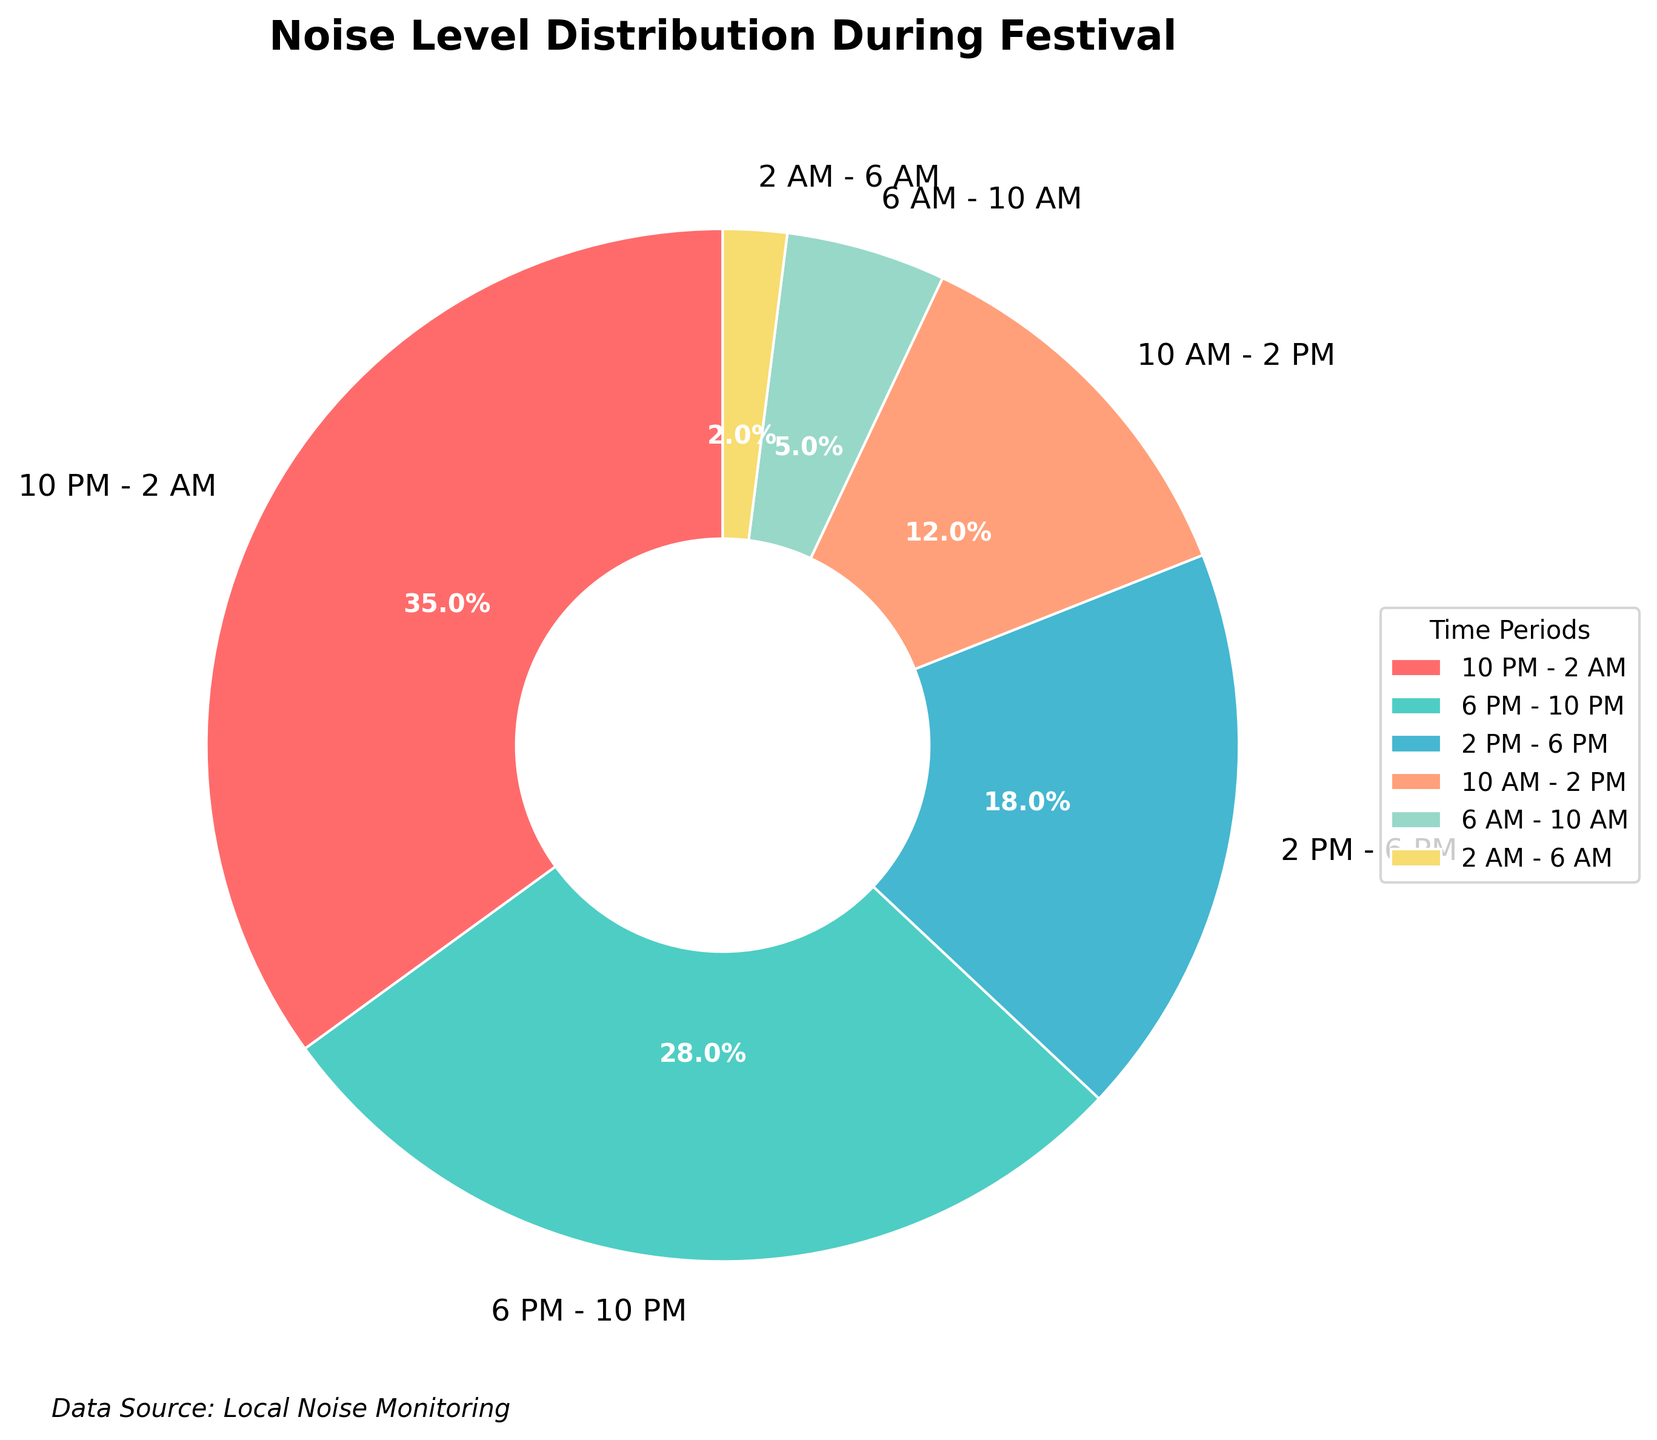Which time period has the highest noise level percentage? The slice representing "10 PM - 2 AM" has the largest portion of the pie chart, with an autopct showing 35%.
Answer: 10 PM - 2 AM What is the combined noise level percentage for the periods between 6 PM and 2 AM? The noise levels for "6 PM - 10 PM" (28%) and "10 PM - 2 AM" (35%) add up to 28% + 35% = 63%.
Answer: 63% Which time period has the lowest noise level percentage? The smallest slice of the pie chart is "2 AM - 6 AM" with an autopct showing 2%.
Answer: 2 AM - 6 AM How much higher is the noise level percentage during "10 PM - 2 AM" compared to "2 PM - 6 PM"? The noise level for "10 PM - 2 AM" is 35%, and for "2 PM - 6 PM" is 18%. The difference is 35% - 18% = 17%.
Answer: 17% What is the average noise level percentage for the three quietest periods? The three quietest periods are "2 AM - 6 AM" (2%), "6 AM - 10 AM" (5%), and "10 AM - 2 PM" (12%). The average is (2% + 5% + 12%) / 3 = 19% / 3 ≈ 6.33%.
Answer: 6.33% What percentage of the total noise level is accounted for by the time periods between 10 AM and 6 PM? The noise levels for "10 AM - 2 PM" (12%) and "2 PM - 6 PM" (18%) add up to 12% + 18% = 30%.
Answer: 30% Which colors correspond to the time periods "6 PM - 10 PM" and "10 AM - 2 PM"? The legend shows "6 PM - 10 PM" is represented by cyan, and "10 AM - 2 PM" is represented by orange.
Answer: Cyan and Orange Compare the combined noise levels of the periods before noon and after noon. Which is higher? The combined noise levels for periods before noon ("6 AM - 10 AM" (5%) and "10 AM - 2 PM" (12%)) is 5% + 12% = 17%. For after noon ("2 PM - 6 PM" (18%), "6 PM - 10 PM" (28%), and "10 PM - 2 AM" (35%)), the sum is 18% + 28% + 35% = 81%. The latter is higher.
Answer: After noon 